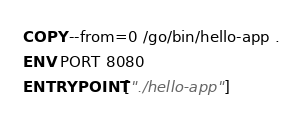Convert code to text. <code><loc_0><loc_0><loc_500><loc_500><_Dockerfile_>COPY --from=0 /go/bin/hello-app .
ENV PORT 8080
ENTRYPOINT ["./hello-app"]
</code> 